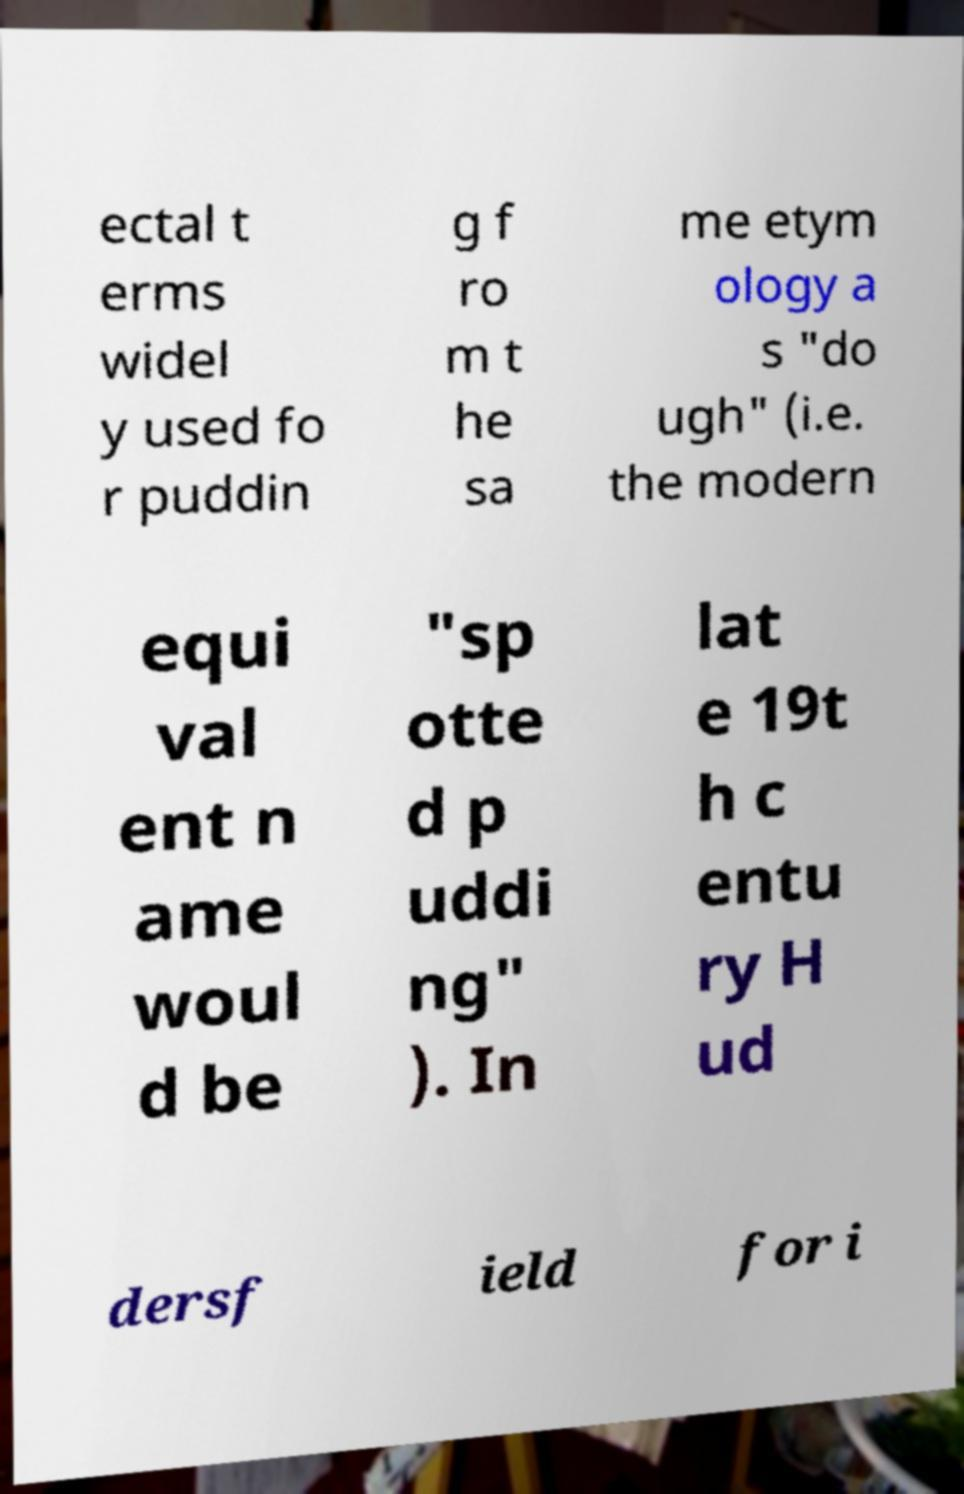Could you extract and type out the text from this image? ectal t erms widel y used fo r puddin g f ro m t he sa me etym ology a s "do ugh" (i.e. the modern equi val ent n ame woul d be "sp otte d p uddi ng" ). In lat e 19t h c entu ry H ud dersf ield for i 